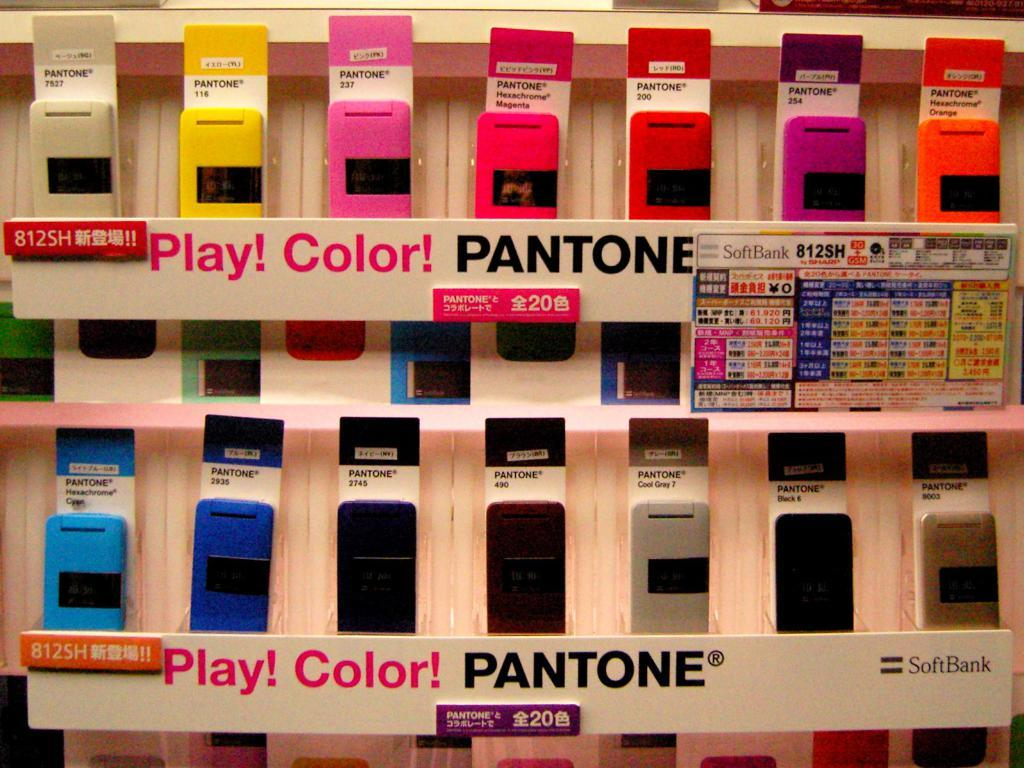<image>
Describe the image concisely. A Pantone display advertises their many different color options. 